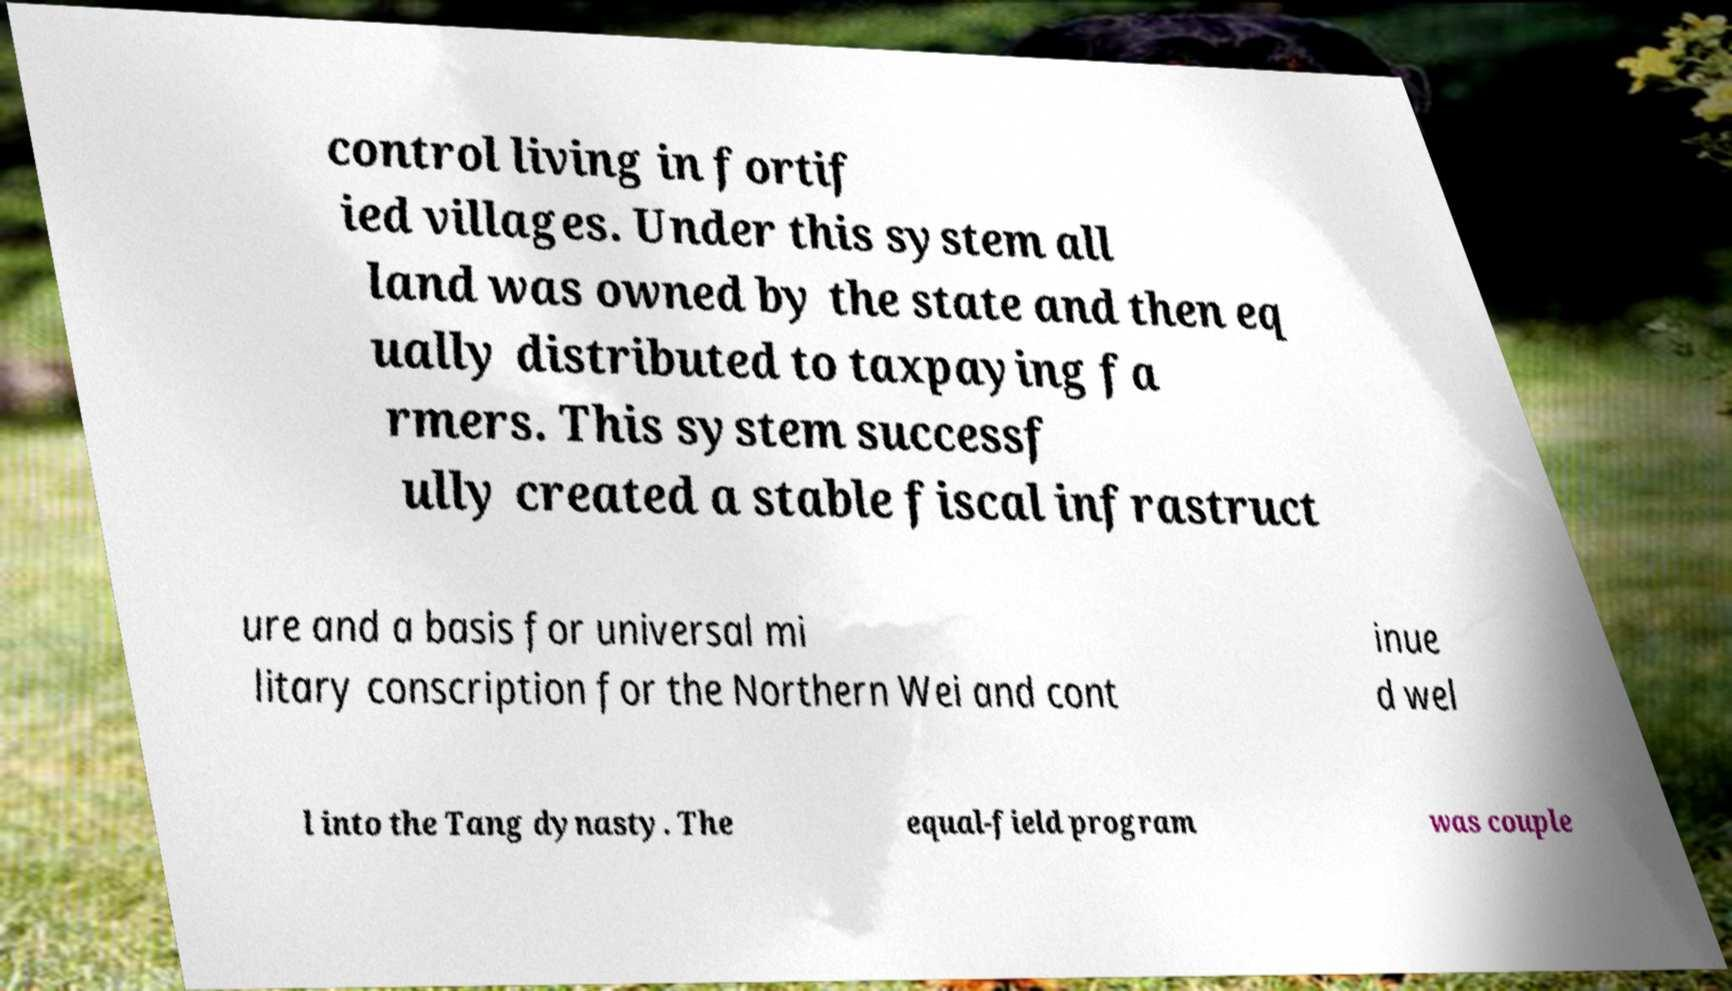What messages or text are displayed in this image? I need them in a readable, typed format. control living in fortif ied villages. Under this system all land was owned by the state and then eq ually distributed to taxpaying fa rmers. This system successf ully created a stable fiscal infrastruct ure and a basis for universal mi litary conscription for the Northern Wei and cont inue d wel l into the Tang dynasty. The equal-field program was couple 